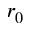Convert formula to latex. <formula><loc_0><loc_0><loc_500><loc_500>r _ { 0 }</formula> 